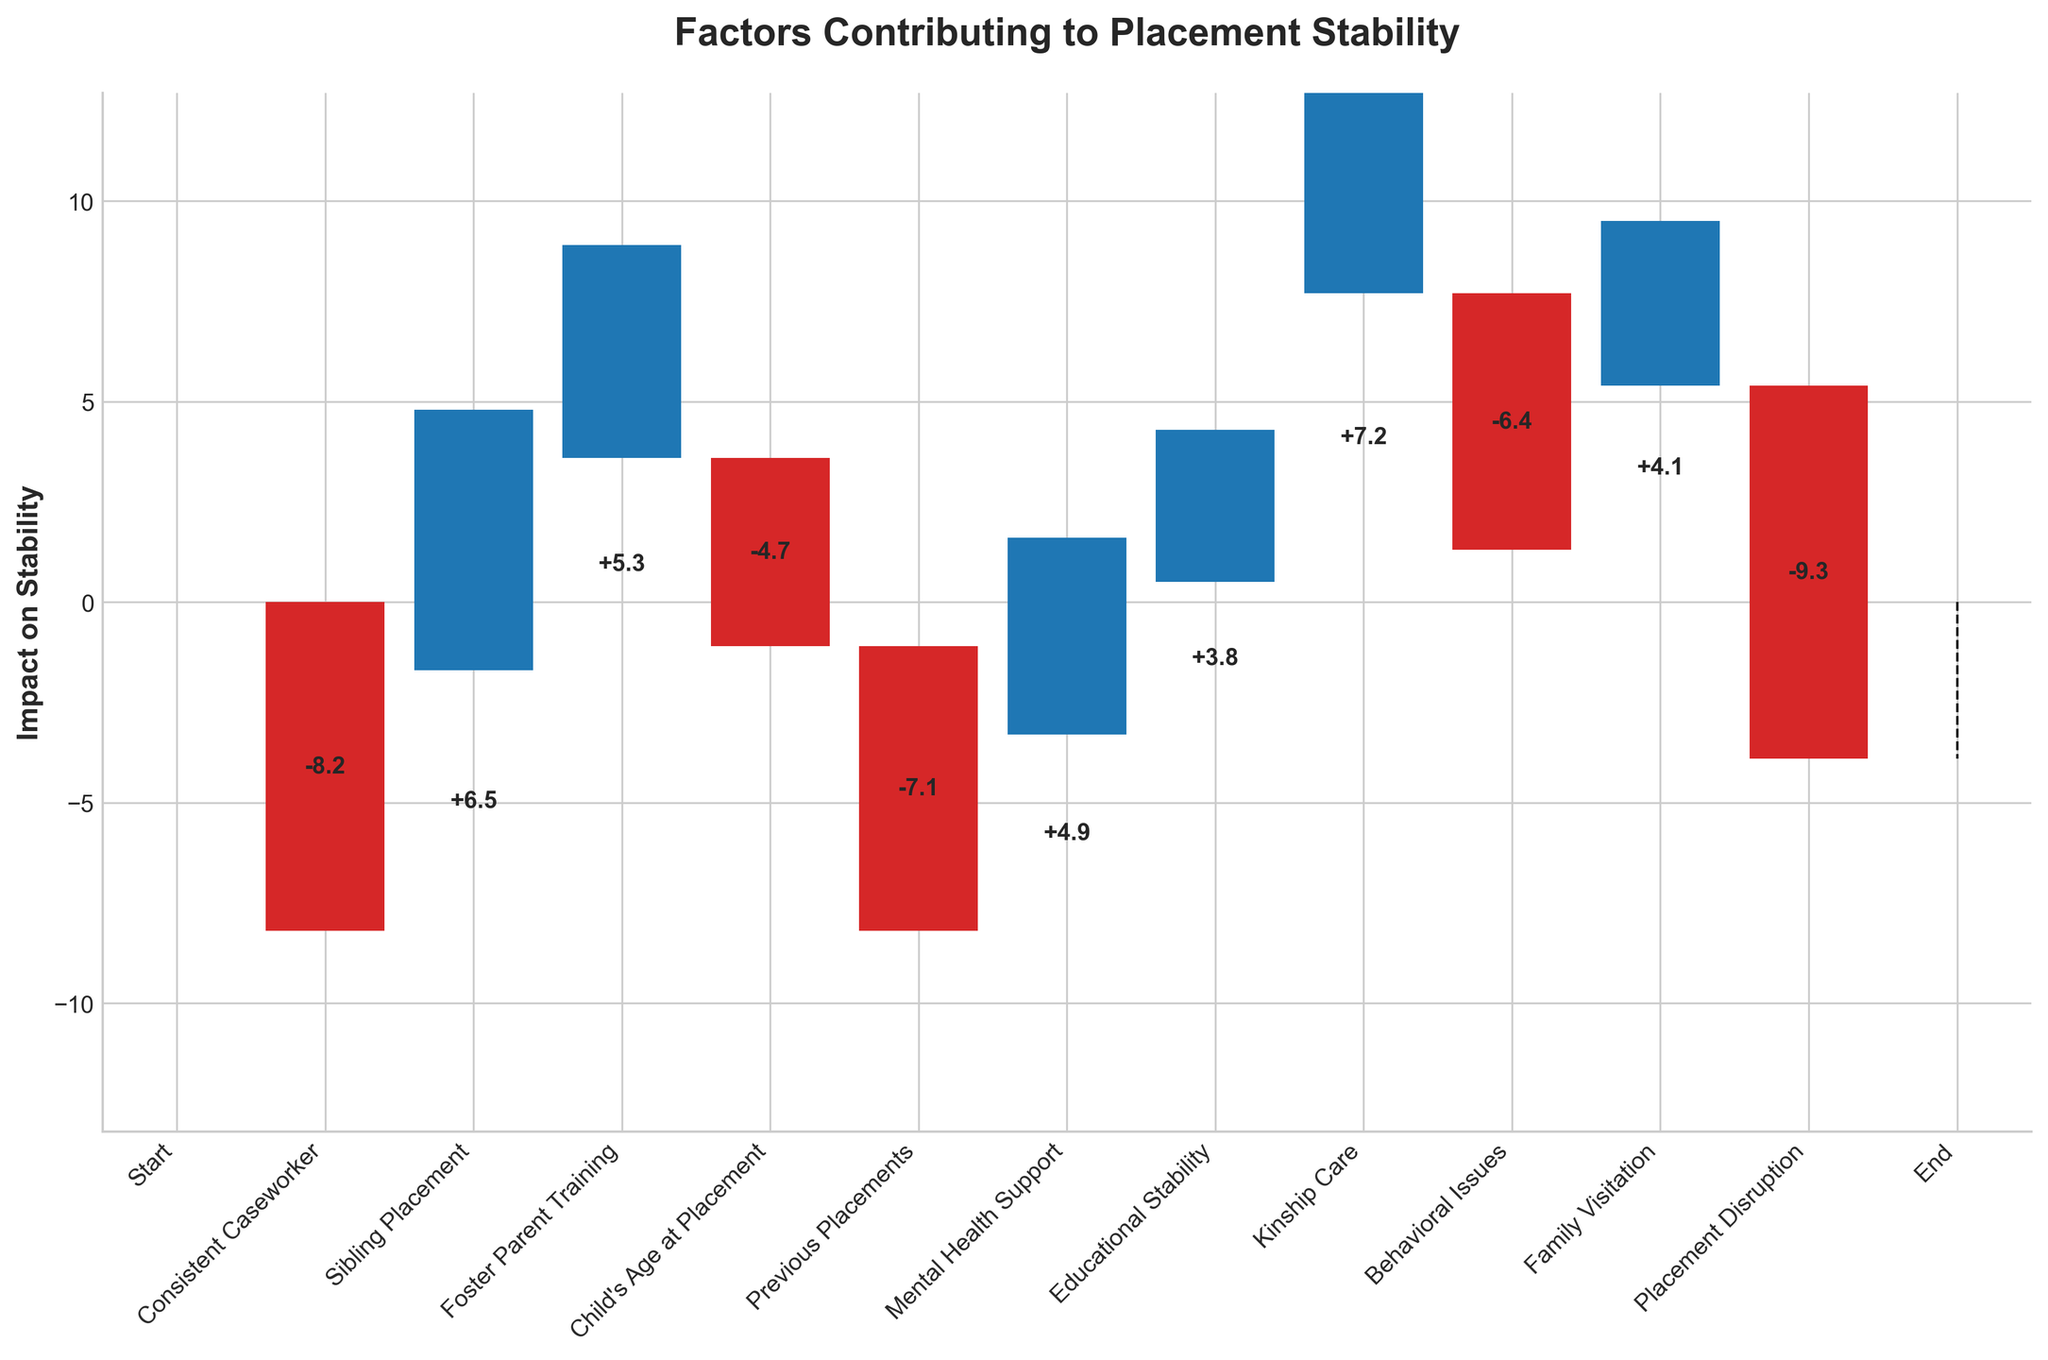What's the title of the chart? The title is usually provided at the top of the chart. In this case, it is prominently displayed.
Answer: Factors Contributing to Placement Stability Which factor has the highest positive impact on placement stability? The highest positive bar, indicating the highest increase, should be identified by visually examining the chart.
Answer: Kinship Care What is the total negative impact on placement stability? To find the total negative impact, sum all the bars representing negative values: Consistent Caseworker (-8.2), Child's Age at Placement (-4.7), Previous Placements (-7.1), Behavioral Issues (-6.4), and Placement Disruption (-9.3). The total is -8.2 + -4.7 + -7.1 + -6.4 + -9.3 = -35.7.
Answer: -35.7 Which factor has the most significant negative impact on placement stability? Identify which bar representing a negative value is the longest.
Answer: Placement Disruption How many positive factors are shown in the chart? Count the number of bars representing positive values: Sibling Placement, Foster Parent Training, Mental Health Support, Educational Stability, Kinship Care, and Family Visitation. There are 6 bars.
Answer: 6 What's the combined impact of Sibling Placement and Kinship Care? Sum the values of Sibling Placement (6.5) and Kinship Care (7.2). 6.5 + 7.2 = 13.7.
Answer: 13.7 What's the net impact of Family Visitation and Behavioral Issues? Calculate the net impact by adding the value of Family Visitation (4.1) and the negative value of Behavioral Issues (-6.4). 4.1 + (-6.4) = -2.3.
Answer: -2.3 What’s the impact of Mental Health Support on placement stability? Read the value associated with Mental Health Support from the chart.
Answer: 4.9 How does the impact of Foster Parent Training compare to Educational Stability? Compare the values of Foster Parent Training (5.3) and Educational Stability (3.8). Foster Parent Training has a higher impact.
Answer: Foster Parent Training is higher What are the labels of the factors with a negative impact on placement stability? List the categories that have negative values: Consistent Caseworker, Child's Age at Placement, Previous Placements, Behavioral Issues, and Placement Disruption.
Answer: Consistent Caseworker, Child's Age at Placement, Previous Placements, Behavioral Issues, Placement Disruption 